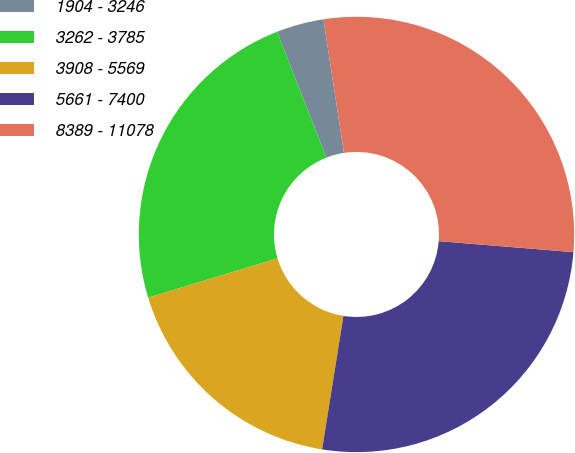Convert chart to OTSL. <chart><loc_0><loc_0><loc_500><loc_500><pie_chart><fcel>1904 - 3246<fcel>3262 - 3785<fcel>3908 - 5569<fcel>5661 - 7400<fcel>8389 - 11078<nl><fcel>3.52%<fcel>23.74%<fcel>17.79%<fcel>26.23%<fcel>28.72%<nl></chart> 